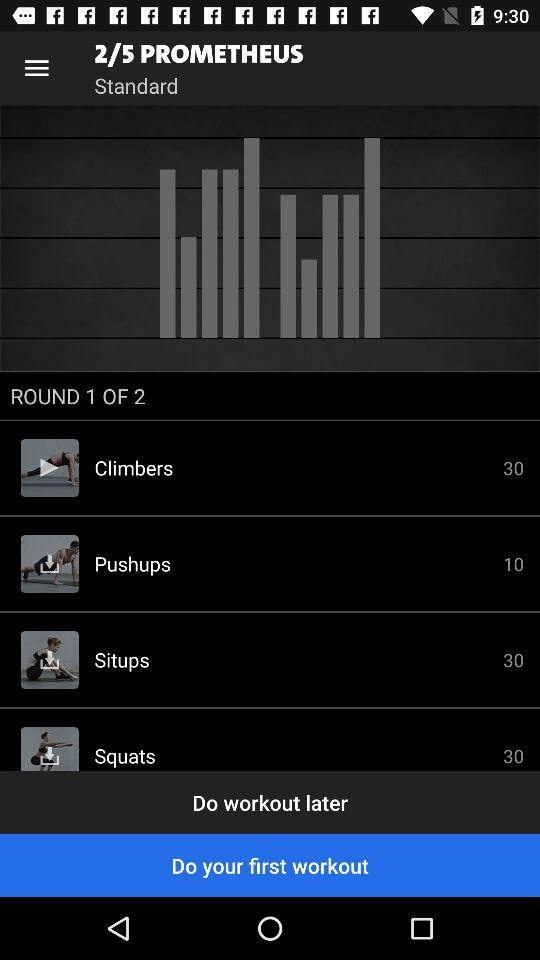What is the number of sets in the "Climbers" exercise? The set in the "Climbers" exercise is 30. 